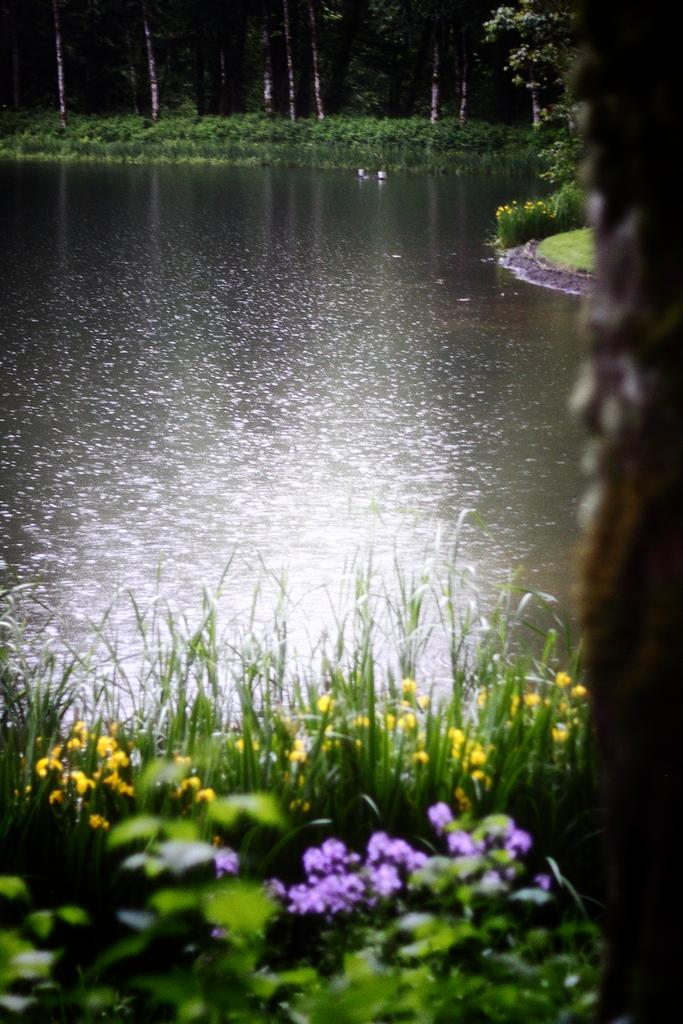What type of plants can be seen in the image? There are colorful flowers and green leaves in the image. What is the primary element visible in the image? Water is visible in the image. What can be seen in the background of the image? In the background of the image, there are flowers, trees, plants, and grass. What type of notebook is visible on the table in the image? There is no notebook present in the image; it features plants and water. Can you tell me how many tanks are visible in the image? There are no tanks present in the image. 